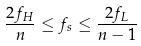<formula> <loc_0><loc_0><loc_500><loc_500>\frac { 2 f _ { H } } { n } \leq f _ { s } \leq \frac { 2 f _ { L } } { n - 1 }</formula> 